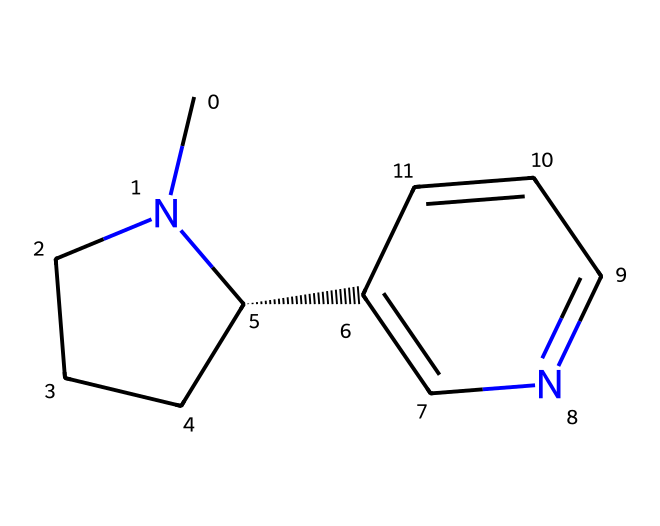What is the main alkaloid found in tobacco? The structure represented by the SMILES code corresponds to nicotine, which is the primary alkaloid found in tobacco plants.
Answer: nicotine How many nitrogen atoms are present in this molecule? Analyzing the SMILES structure, there are two nitrogen atoms represented. The presence of nitrogen is typical in alkaloids, which often contain basic amine groups.
Answer: two What is the total number of carbon atoms in nicotine? From the SMILES representation, counting the carbon atoms gives a total of 10 carbon atoms in the nicotine structure.
Answer: ten Is nicotine a polar or nonpolar molecule? Given the structure, nicotine has regions of polarity due to the presence of nitrogen atoms and the structure itself, suggesting it is relatively polar compared to purely hydrocarbon structures, but can be classified as moderately polar.
Answer: polar What chemical properties does nicotine exhibit due to its alkaloid nature? The nitrogen atoms contribute to the basicity and pharmacological properties of nicotine, as they allow the molecule to interact with neurotransmitter receptors in the nervous system, which is characteristic behavior of alkaloids.
Answer: basicity and pharmacological properties How many rings are present in the nicotine structure? The SMILES representation indicates that nicotine has one cyclic structure, which is part of the typical characteristics of many alkaloids, contributing to their unique biological activities.
Answer: one What role do the nitrogen atoms play in nicotine's interaction with receptors? The nitrogen atoms are crucial for binding to nicotinic acetylcholine receptors in the nervous system, which is fundamental to nicotine's effects, including its addictive properties, typical for alkaloids.
Answer: receptor binding 